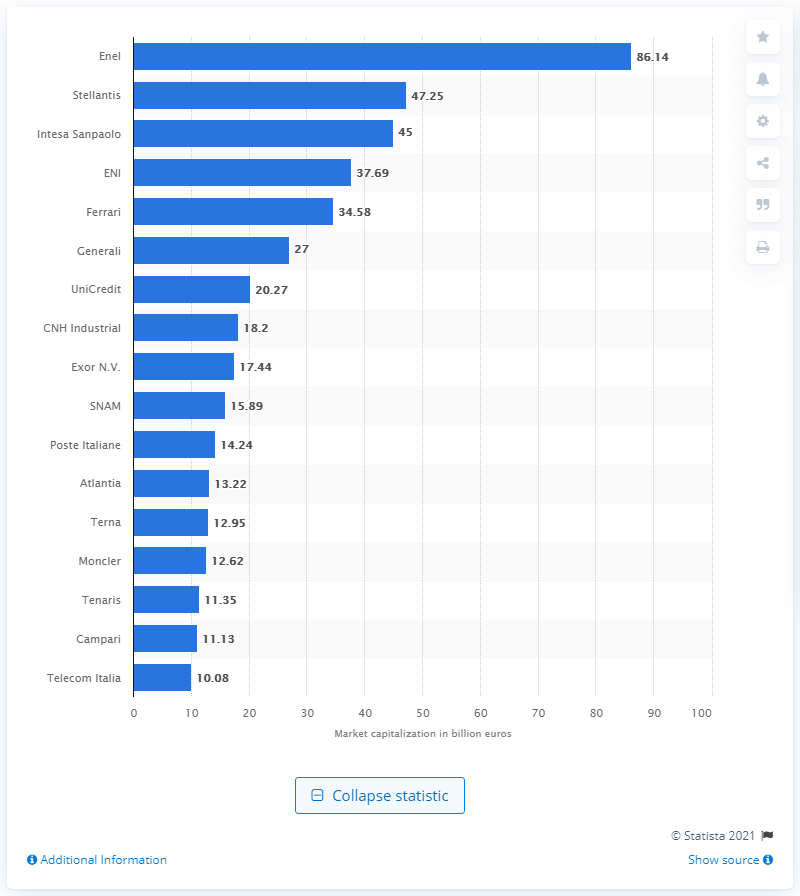Indicate a few pertinent items in this graphic. As of March 2021, Enel was the largest company listed on the Milan Stock Exchange. Intesa Sanpaolo is the 14th largest bank in Europe. 